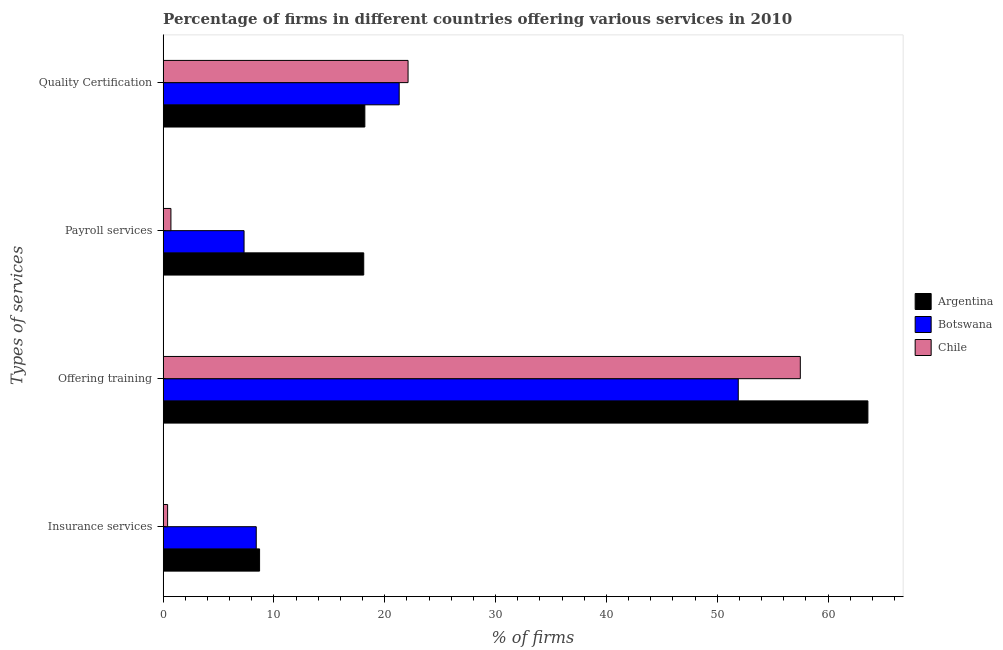How many different coloured bars are there?
Offer a very short reply. 3. How many groups of bars are there?
Offer a terse response. 4. Are the number of bars per tick equal to the number of legend labels?
Keep it short and to the point. Yes. Are the number of bars on each tick of the Y-axis equal?
Provide a short and direct response. Yes. What is the label of the 1st group of bars from the top?
Offer a very short reply. Quality Certification. What is the percentage of firms offering payroll services in Argentina?
Make the answer very short. 18.1. Across all countries, what is the maximum percentage of firms offering insurance services?
Provide a succinct answer. 8.7. Across all countries, what is the minimum percentage of firms offering insurance services?
Offer a very short reply. 0.4. In which country was the percentage of firms offering training minimum?
Offer a very short reply. Botswana. What is the difference between the percentage of firms offering payroll services in Chile and that in Argentina?
Keep it short and to the point. -17.4. What is the difference between the percentage of firms offering training in Argentina and the percentage of firms offering insurance services in Botswana?
Your answer should be compact. 55.2. What is the average percentage of firms offering insurance services per country?
Offer a terse response. 5.83. What is the difference between the percentage of firms offering quality certification and percentage of firms offering payroll services in Argentina?
Ensure brevity in your answer.  0.1. What is the ratio of the percentage of firms offering quality certification in Botswana to that in Argentina?
Offer a terse response. 1.17. Is the percentage of firms offering insurance services in Botswana less than that in Argentina?
Your answer should be compact. Yes. Is the difference between the percentage of firms offering quality certification in Argentina and Botswana greater than the difference between the percentage of firms offering insurance services in Argentina and Botswana?
Provide a succinct answer. No. What is the difference between the highest and the second highest percentage of firms offering quality certification?
Give a very brief answer. 0.8. What is the difference between the highest and the lowest percentage of firms offering insurance services?
Provide a short and direct response. 8.3. What does the 3rd bar from the top in Payroll services represents?
Ensure brevity in your answer.  Argentina. Is it the case that in every country, the sum of the percentage of firms offering insurance services and percentage of firms offering training is greater than the percentage of firms offering payroll services?
Provide a succinct answer. Yes. Are all the bars in the graph horizontal?
Make the answer very short. Yes. How many countries are there in the graph?
Your response must be concise. 3. Are the values on the major ticks of X-axis written in scientific E-notation?
Provide a short and direct response. No. Does the graph contain grids?
Offer a terse response. No. Where does the legend appear in the graph?
Ensure brevity in your answer.  Center right. How are the legend labels stacked?
Your response must be concise. Vertical. What is the title of the graph?
Keep it short and to the point. Percentage of firms in different countries offering various services in 2010. What is the label or title of the X-axis?
Keep it short and to the point. % of firms. What is the label or title of the Y-axis?
Make the answer very short. Types of services. What is the % of firms of Argentina in Insurance services?
Make the answer very short. 8.7. What is the % of firms in Chile in Insurance services?
Provide a short and direct response. 0.4. What is the % of firms in Argentina in Offering training?
Offer a very short reply. 63.6. What is the % of firms of Botswana in Offering training?
Your answer should be compact. 51.9. What is the % of firms of Chile in Offering training?
Ensure brevity in your answer.  57.5. What is the % of firms in Botswana in Payroll services?
Offer a terse response. 7.3. What is the % of firms of Chile in Payroll services?
Ensure brevity in your answer.  0.7. What is the % of firms of Argentina in Quality Certification?
Ensure brevity in your answer.  18.2. What is the % of firms of Botswana in Quality Certification?
Ensure brevity in your answer.  21.3. What is the % of firms of Chile in Quality Certification?
Provide a succinct answer. 22.1. Across all Types of services, what is the maximum % of firms in Argentina?
Offer a terse response. 63.6. Across all Types of services, what is the maximum % of firms of Botswana?
Your answer should be very brief. 51.9. Across all Types of services, what is the maximum % of firms of Chile?
Provide a succinct answer. 57.5. What is the total % of firms of Argentina in the graph?
Your response must be concise. 108.6. What is the total % of firms of Botswana in the graph?
Your response must be concise. 88.9. What is the total % of firms of Chile in the graph?
Keep it short and to the point. 80.7. What is the difference between the % of firms of Argentina in Insurance services and that in Offering training?
Make the answer very short. -54.9. What is the difference between the % of firms of Botswana in Insurance services and that in Offering training?
Offer a very short reply. -43.5. What is the difference between the % of firms in Chile in Insurance services and that in Offering training?
Your response must be concise. -57.1. What is the difference between the % of firms of Chile in Insurance services and that in Payroll services?
Your answer should be very brief. -0.3. What is the difference between the % of firms in Chile in Insurance services and that in Quality Certification?
Make the answer very short. -21.7. What is the difference between the % of firms in Argentina in Offering training and that in Payroll services?
Ensure brevity in your answer.  45.5. What is the difference between the % of firms in Botswana in Offering training and that in Payroll services?
Keep it short and to the point. 44.6. What is the difference between the % of firms in Chile in Offering training and that in Payroll services?
Provide a short and direct response. 56.8. What is the difference between the % of firms of Argentina in Offering training and that in Quality Certification?
Your answer should be very brief. 45.4. What is the difference between the % of firms of Botswana in Offering training and that in Quality Certification?
Offer a very short reply. 30.6. What is the difference between the % of firms of Chile in Offering training and that in Quality Certification?
Provide a short and direct response. 35.4. What is the difference between the % of firms in Chile in Payroll services and that in Quality Certification?
Make the answer very short. -21.4. What is the difference between the % of firms in Argentina in Insurance services and the % of firms in Botswana in Offering training?
Provide a succinct answer. -43.2. What is the difference between the % of firms in Argentina in Insurance services and the % of firms in Chile in Offering training?
Provide a short and direct response. -48.8. What is the difference between the % of firms of Botswana in Insurance services and the % of firms of Chile in Offering training?
Give a very brief answer. -49.1. What is the difference between the % of firms of Argentina in Insurance services and the % of firms of Botswana in Payroll services?
Provide a succinct answer. 1.4. What is the difference between the % of firms of Argentina in Insurance services and the % of firms of Chile in Payroll services?
Your answer should be very brief. 8. What is the difference between the % of firms of Botswana in Insurance services and the % of firms of Chile in Quality Certification?
Your answer should be compact. -13.7. What is the difference between the % of firms of Argentina in Offering training and the % of firms of Botswana in Payroll services?
Provide a succinct answer. 56.3. What is the difference between the % of firms of Argentina in Offering training and the % of firms of Chile in Payroll services?
Offer a very short reply. 62.9. What is the difference between the % of firms in Botswana in Offering training and the % of firms in Chile in Payroll services?
Offer a terse response. 51.2. What is the difference between the % of firms in Argentina in Offering training and the % of firms in Botswana in Quality Certification?
Make the answer very short. 42.3. What is the difference between the % of firms in Argentina in Offering training and the % of firms in Chile in Quality Certification?
Your answer should be very brief. 41.5. What is the difference between the % of firms in Botswana in Offering training and the % of firms in Chile in Quality Certification?
Offer a terse response. 29.8. What is the difference between the % of firms of Argentina in Payroll services and the % of firms of Chile in Quality Certification?
Your answer should be compact. -4. What is the difference between the % of firms in Botswana in Payroll services and the % of firms in Chile in Quality Certification?
Make the answer very short. -14.8. What is the average % of firms in Argentina per Types of services?
Ensure brevity in your answer.  27.15. What is the average % of firms in Botswana per Types of services?
Provide a short and direct response. 22.23. What is the average % of firms of Chile per Types of services?
Your answer should be compact. 20.18. What is the difference between the % of firms of Argentina and % of firms of Chile in Insurance services?
Offer a very short reply. 8.3. What is the difference between the % of firms of Argentina and % of firms of Chile in Offering training?
Provide a short and direct response. 6.1. What is the difference between the % of firms of Botswana and % of firms of Chile in Offering training?
Offer a very short reply. -5.6. What is the difference between the % of firms of Argentina and % of firms of Botswana in Payroll services?
Your answer should be compact. 10.8. What is the difference between the % of firms in Botswana and % of firms in Chile in Payroll services?
Keep it short and to the point. 6.6. What is the ratio of the % of firms of Argentina in Insurance services to that in Offering training?
Ensure brevity in your answer.  0.14. What is the ratio of the % of firms of Botswana in Insurance services to that in Offering training?
Your answer should be very brief. 0.16. What is the ratio of the % of firms of Chile in Insurance services to that in Offering training?
Offer a very short reply. 0.01. What is the ratio of the % of firms of Argentina in Insurance services to that in Payroll services?
Make the answer very short. 0.48. What is the ratio of the % of firms of Botswana in Insurance services to that in Payroll services?
Provide a succinct answer. 1.15. What is the ratio of the % of firms in Argentina in Insurance services to that in Quality Certification?
Provide a short and direct response. 0.48. What is the ratio of the % of firms of Botswana in Insurance services to that in Quality Certification?
Offer a very short reply. 0.39. What is the ratio of the % of firms in Chile in Insurance services to that in Quality Certification?
Your response must be concise. 0.02. What is the ratio of the % of firms in Argentina in Offering training to that in Payroll services?
Your response must be concise. 3.51. What is the ratio of the % of firms of Botswana in Offering training to that in Payroll services?
Your answer should be compact. 7.11. What is the ratio of the % of firms in Chile in Offering training to that in Payroll services?
Your answer should be very brief. 82.14. What is the ratio of the % of firms in Argentina in Offering training to that in Quality Certification?
Provide a short and direct response. 3.49. What is the ratio of the % of firms in Botswana in Offering training to that in Quality Certification?
Your answer should be very brief. 2.44. What is the ratio of the % of firms of Chile in Offering training to that in Quality Certification?
Offer a very short reply. 2.6. What is the ratio of the % of firms of Argentina in Payroll services to that in Quality Certification?
Give a very brief answer. 0.99. What is the ratio of the % of firms in Botswana in Payroll services to that in Quality Certification?
Provide a short and direct response. 0.34. What is the ratio of the % of firms of Chile in Payroll services to that in Quality Certification?
Give a very brief answer. 0.03. What is the difference between the highest and the second highest % of firms of Argentina?
Make the answer very short. 45.4. What is the difference between the highest and the second highest % of firms of Botswana?
Your answer should be very brief. 30.6. What is the difference between the highest and the second highest % of firms in Chile?
Your answer should be very brief. 35.4. What is the difference between the highest and the lowest % of firms in Argentina?
Make the answer very short. 54.9. What is the difference between the highest and the lowest % of firms of Botswana?
Offer a very short reply. 44.6. What is the difference between the highest and the lowest % of firms in Chile?
Give a very brief answer. 57.1. 